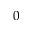Convert formula to latex. <formula><loc_0><loc_0><loc_500><loc_500>0</formula> 